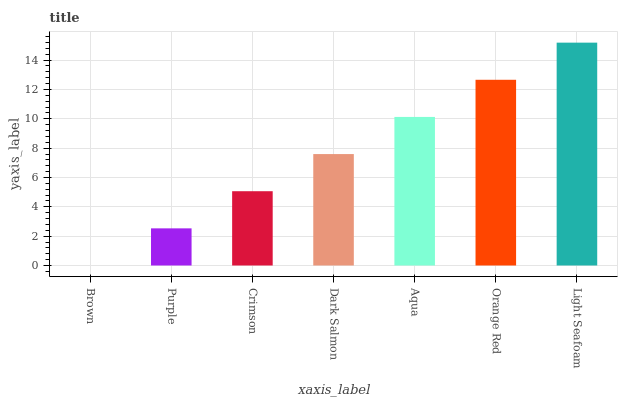Is Brown the minimum?
Answer yes or no. Yes. Is Light Seafoam the maximum?
Answer yes or no. Yes. Is Purple the minimum?
Answer yes or no. No. Is Purple the maximum?
Answer yes or no. No. Is Purple greater than Brown?
Answer yes or no. Yes. Is Brown less than Purple?
Answer yes or no. Yes. Is Brown greater than Purple?
Answer yes or no. No. Is Purple less than Brown?
Answer yes or no. No. Is Dark Salmon the high median?
Answer yes or no. Yes. Is Dark Salmon the low median?
Answer yes or no. Yes. Is Aqua the high median?
Answer yes or no. No. Is Aqua the low median?
Answer yes or no. No. 